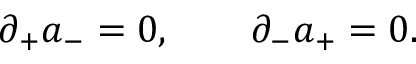<formula> <loc_0><loc_0><loc_500><loc_500>\partial _ { + } a _ { - } = 0 , \quad \partial _ { - } a _ { + } = 0 .</formula> 